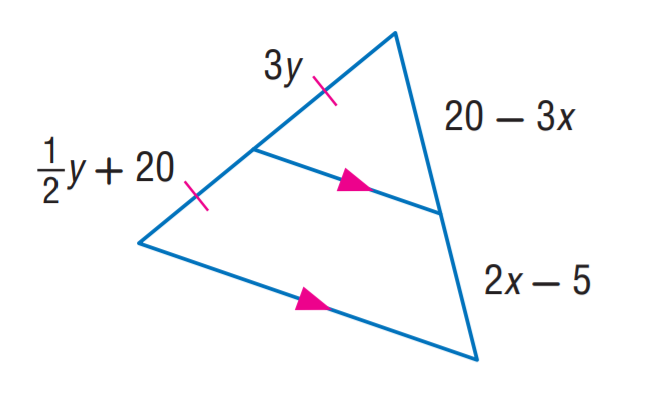Answer the mathemtical geometry problem and directly provide the correct option letter.
Question: Find x.
Choices: A: 3 B: 5 C: 6 D: 8 B 